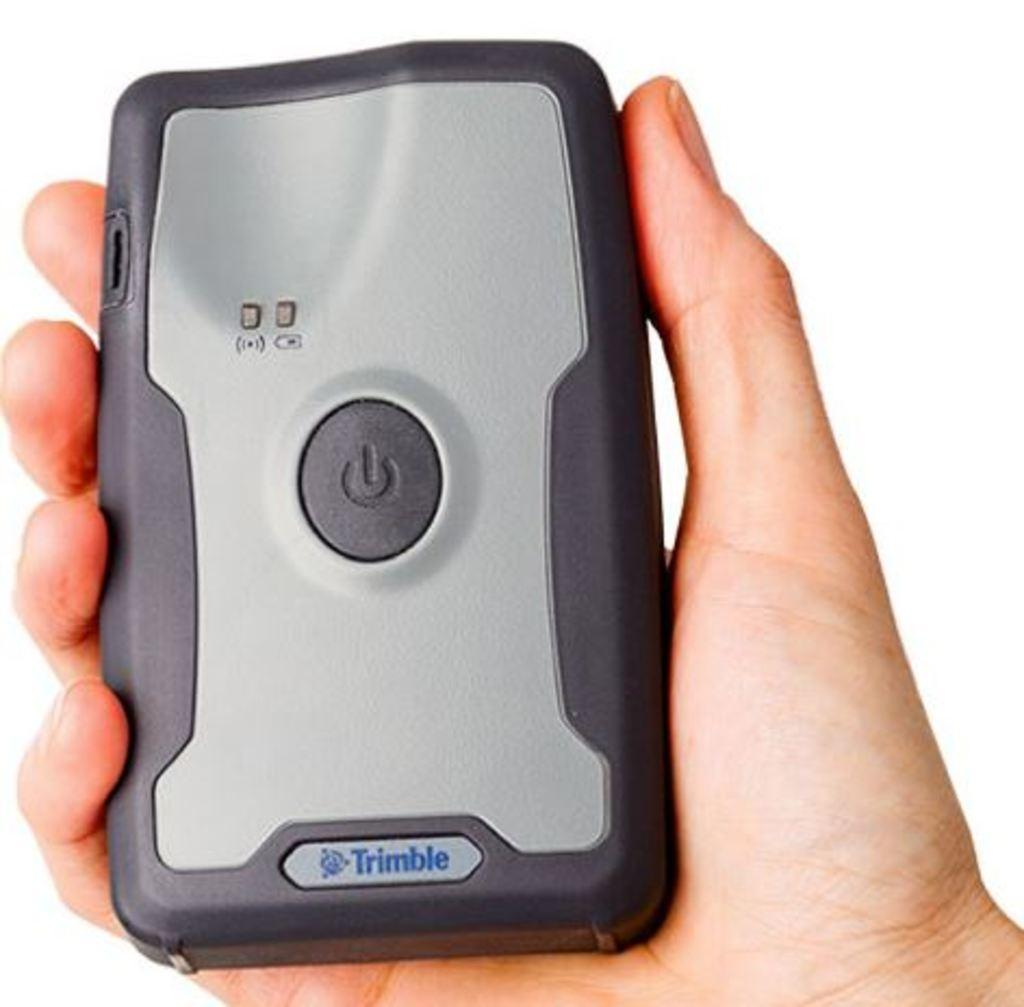What is the main object in the image? There is an electronic gadget in the image. Who is holding the electronic gadget? The electronic gadget is being held by a person. What color is the background of the image? The background of the image is white in color. How many legs can be seen on the electronic gadget in the image? The electronic gadget does not have legs; it is an object without limbs. 